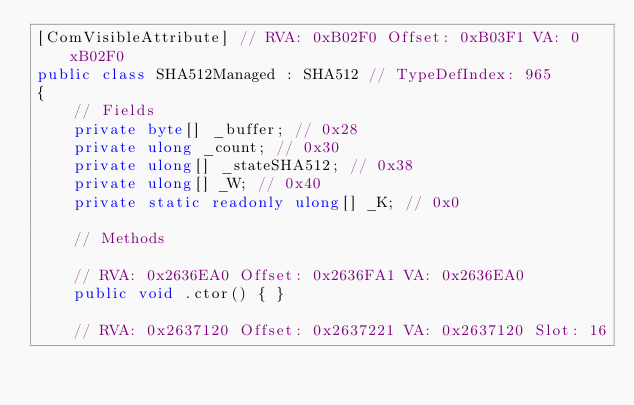Convert code to text. <code><loc_0><loc_0><loc_500><loc_500><_C#_>[ComVisibleAttribute] // RVA: 0xB02F0 Offset: 0xB03F1 VA: 0xB02F0
public class SHA512Managed : SHA512 // TypeDefIndex: 965
{
	// Fields
	private byte[] _buffer; // 0x28
	private ulong _count; // 0x30
	private ulong[] _stateSHA512; // 0x38
	private ulong[] _W; // 0x40
	private static readonly ulong[] _K; // 0x0

	// Methods

	// RVA: 0x2636EA0 Offset: 0x2636FA1 VA: 0x2636EA0
	public void .ctor() { }

	// RVA: 0x2637120 Offset: 0x2637221 VA: 0x2637120 Slot: 16</code> 